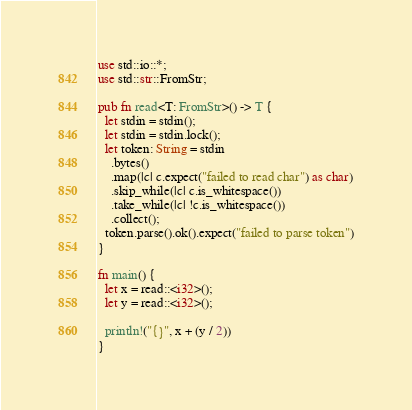Convert code to text. <code><loc_0><loc_0><loc_500><loc_500><_Rust_>
use std::io::*;
use std::str::FromStr;

pub fn read<T: FromStr>() -> T {
  let stdin = stdin();
  let stdin = stdin.lock();
  let token: String = stdin
    .bytes()
    .map(|c| c.expect("failed to read char") as char)
    .skip_while(|c| c.is_whitespace())
    .take_while(|c| !c.is_whitespace())
    .collect();
  token.parse().ok().expect("failed to parse token")
}

fn main() {
  let x = read::<i32>();
  let y = read::<i32>();

  println!("{}", x + (y / 2))
}

</code> 